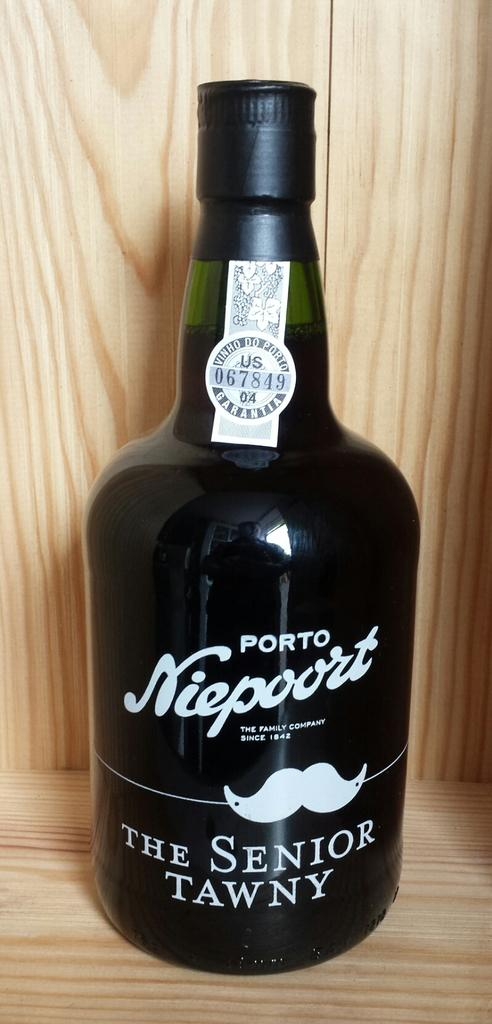<image>
Summarize the visual content of the image. a bottle of porto niepoort senior tawny wine 